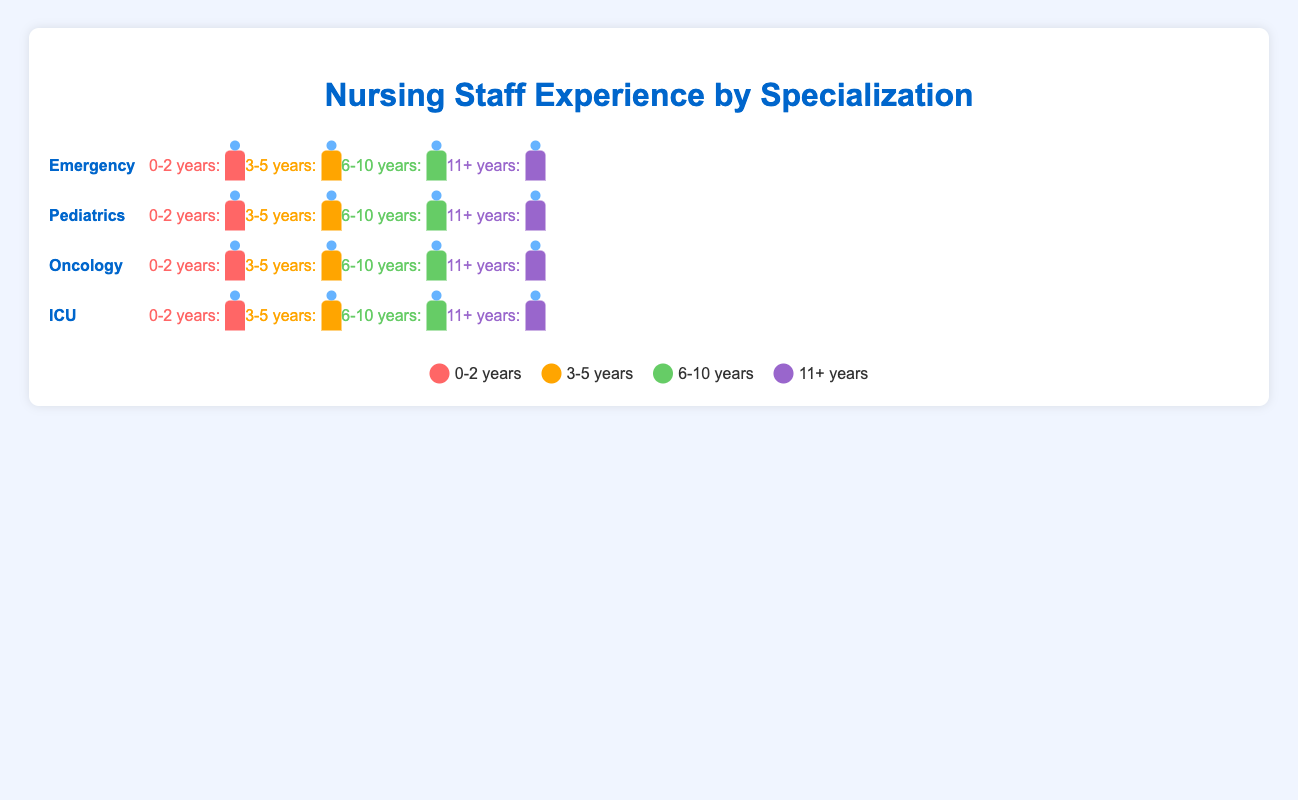How many nurses with 0-2 years of experience are in the Pediatrics specialization? Look at the Pediatrics specialization row and count the nurse icons in the 0-2 years experience group. There are 12 icons representing nurses with 0-2 years of experience in Pediatrics.
Answer: 12 Which specialization has the highest number of nurses with 6-10 years of experience? Compare the count of nurse icons in the 6-10 years experience group across all specializations. ICU has the highest count with 25 icons.
Answer: ICU What is the total number of nurses in the Oncology specialization? Add the counts of nurse icons for all experience groups within the Oncology specialization (8 + 13 + 17 + 12).
Answer: 50 What is the difference in the number of nurses with 11+ years of experience between the Emergency and ICU specializations? Subtract the count of nurses with 11+ years of experience in Emergency (10) from those in ICU (15).
Answer: 5 Which specialization has the lowest number of nurses with 0-2 years of experience? Compare the count of nurse icons in the 0-2 years experience group across all specializations. Oncology has the lowest count with 8 icons.
Answer: Oncology How many more nurses with 3-5 years of experience work in ICU compared to Pediatrics? Subtract the number of nurses with 3-5 years of experience in Pediatrics (16) from those in ICU (18).
Answer: 2 In the Emergency specialization, which experience group has the second-highest number of nurses? Within the Emergency specialization row, identify the experience group with the second-highest count of nurse icons. The experience group with 3-5 years has 22 nurses, making it the highest, and the group with 6-10 years has 18 nurses, making it the second highest.
Answer: 6-10 years How many total nurses in the ICU specialization have 0-5 years of experience? Add the counts of nurse icons for the 0-2 years and 3-5 years experience groups within the ICU specialization (10 + 18).
Answer: 28 Which experience group has the highest number of nurses across all specializations? Compare the count of nurses in each experience group across all specializations. ICU's 6-10 years experience group with 25 nurses is the highest.
Answer: 6-10 years in ICU 